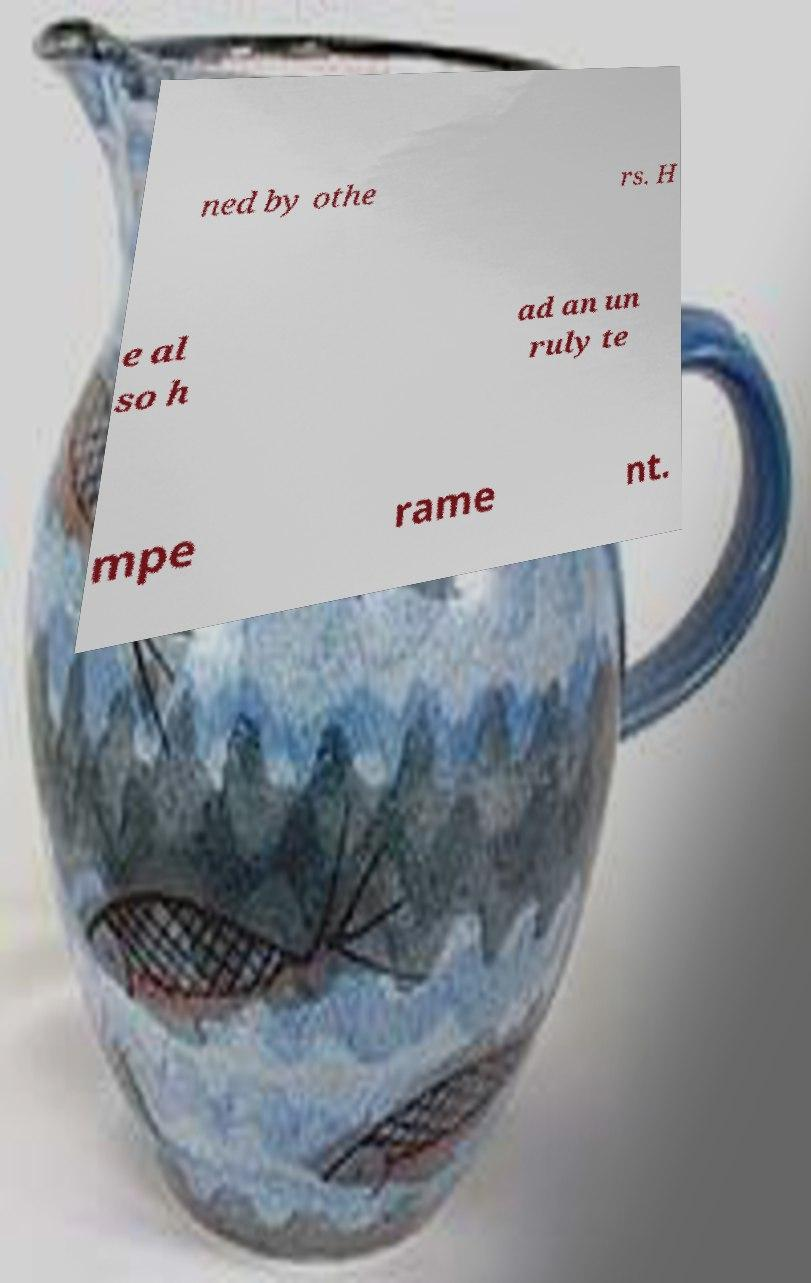There's text embedded in this image that I need extracted. Can you transcribe it verbatim? ned by othe rs. H e al so h ad an un ruly te mpe rame nt. 